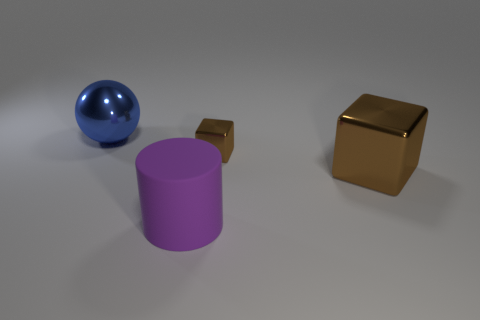Is the number of large balls less than the number of large metallic objects?
Give a very brief answer. Yes. What is the size of the metallic object that is both to the left of the big brown shiny object and in front of the blue shiny thing?
Offer a very short reply. Small. There is a brown object left of the large metallic thing in front of the big metallic thing that is behind the big brown shiny block; what is its size?
Provide a short and direct response. Small. The purple thing is what size?
Ensure brevity in your answer.  Large. Is there any other thing that has the same material as the small brown object?
Make the answer very short. Yes. Are there any blocks that are to the right of the big purple object that is to the left of the big metallic object that is in front of the metal sphere?
Give a very brief answer. Yes. What number of big things are either blue balls or brown metallic blocks?
Ensure brevity in your answer.  2. Is there anything else of the same color as the tiny metallic block?
Your answer should be very brief. Yes. There is a metallic thing that is on the left side of the purple matte object; does it have the same size as the tiny cube?
Make the answer very short. No. What is the color of the metallic block that is behind the large shiny object to the right of the big thing behind the small brown block?
Your response must be concise. Brown. 